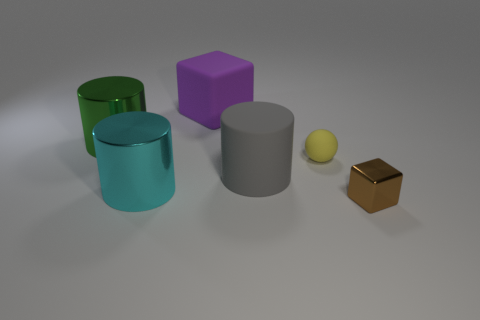Subtract all large green shiny cylinders. How many cylinders are left? 2 Add 1 matte spheres. How many objects exist? 7 Subtract all purple blocks. How many blocks are left? 1 Subtract 0 red cubes. How many objects are left? 6 Subtract all blocks. How many objects are left? 4 Subtract 1 blocks. How many blocks are left? 1 Subtract all green balls. Subtract all green cylinders. How many balls are left? 1 Subtract all cyan balls. How many purple cubes are left? 1 Subtract all small cyan shiny cylinders. Subtract all brown metallic objects. How many objects are left? 5 Add 3 metallic cylinders. How many metallic cylinders are left? 5 